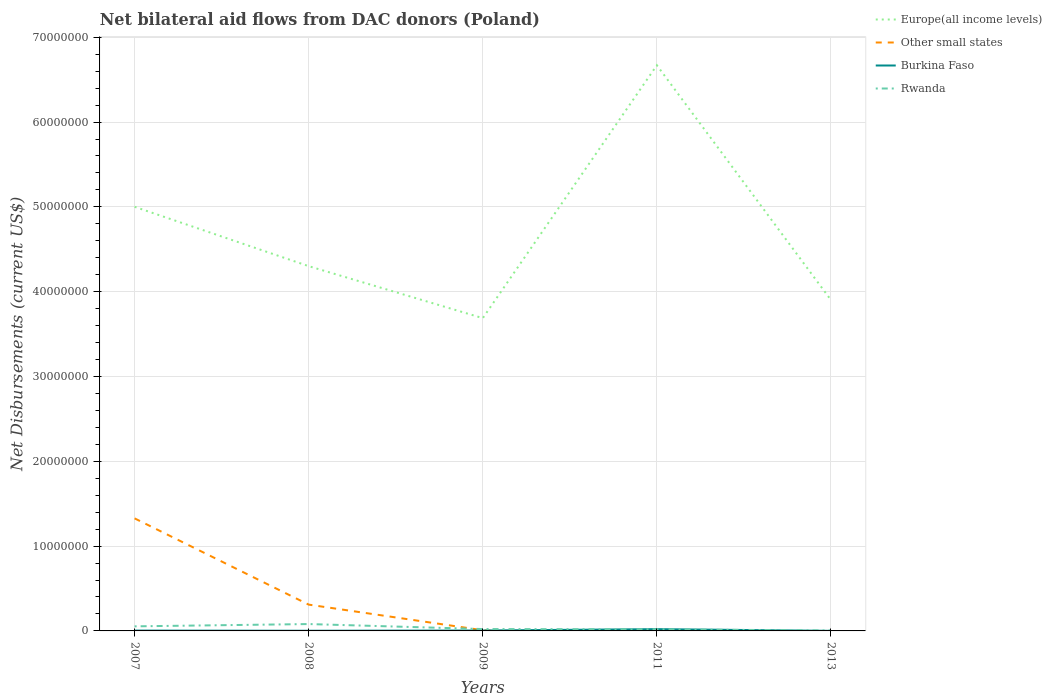Is the number of lines equal to the number of legend labels?
Offer a very short reply. No. What is the total net bilateral aid flows in Europe(all income levels) in the graph?
Give a very brief answer. 6.13e+06. What is the difference between the highest and the second highest net bilateral aid flows in Europe(all income levels)?
Your answer should be very brief. 2.98e+07. What is the difference between the highest and the lowest net bilateral aid flows in Burkina Faso?
Make the answer very short. 1. Is the net bilateral aid flows in Rwanda strictly greater than the net bilateral aid flows in Other small states over the years?
Your response must be concise. No. How many years are there in the graph?
Give a very brief answer. 5. What is the difference between two consecutive major ticks on the Y-axis?
Your answer should be very brief. 1.00e+07. How are the legend labels stacked?
Ensure brevity in your answer.  Vertical. What is the title of the graph?
Your response must be concise. Net bilateral aid flows from DAC donors (Poland). What is the label or title of the X-axis?
Give a very brief answer. Years. What is the label or title of the Y-axis?
Offer a very short reply. Net Disbursements (current US$). What is the Net Disbursements (current US$) in Europe(all income levels) in 2007?
Give a very brief answer. 5.00e+07. What is the Net Disbursements (current US$) of Other small states in 2007?
Your response must be concise. 1.33e+07. What is the Net Disbursements (current US$) of Burkina Faso in 2007?
Your answer should be very brief. 4.00e+04. What is the Net Disbursements (current US$) of Rwanda in 2007?
Ensure brevity in your answer.  5.40e+05. What is the Net Disbursements (current US$) of Europe(all income levels) in 2008?
Your answer should be very brief. 4.30e+07. What is the Net Disbursements (current US$) of Other small states in 2008?
Your response must be concise. 3.10e+06. What is the Net Disbursements (current US$) in Rwanda in 2008?
Provide a succinct answer. 8.10e+05. What is the Net Disbursements (current US$) in Europe(all income levels) in 2009?
Provide a succinct answer. 3.69e+07. What is the Net Disbursements (current US$) in Other small states in 2009?
Your answer should be very brief. 8.00e+04. What is the Net Disbursements (current US$) of Rwanda in 2009?
Provide a succinct answer. 2.20e+05. What is the Net Disbursements (current US$) in Europe(all income levels) in 2011?
Keep it short and to the point. 6.67e+07. What is the Net Disbursements (current US$) of Other small states in 2011?
Make the answer very short. 0. What is the Net Disbursements (current US$) in Europe(all income levels) in 2013?
Make the answer very short. 3.90e+07. Across all years, what is the maximum Net Disbursements (current US$) of Europe(all income levels)?
Give a very brief answer. 6.67e+07. Across all years, what is the maximum Net Disbursements (current US$) of Other small states?
Give a very brief answer. 1.33e+07. Across all years, what is the maximum Net Disbursements (current US$) in Burkina Faso?
Ensure brevity in your answer.  2.10e+05. Across all years, what is the maximum Net Disbursements (current US$) in Rwanda?
Make the answer very short. 8.10e+05. Across all years, what is the minimum Net Disbursements (current US$) in Europe(all income levels)?
Provide a short and direct response. 3.69e+07. What is the total Net Disbursements (current US$) of Europe(all income levels) in the graph?
Offer a very short reply. 2.36e+08. What is the total Net Disbursements (current US$) in Other small states in the graph?
Make the answer very short. 1.64e+07. What is the total Net Disbursements (current US$) of Rwanda in the graph?
Provide a succinct answer. 1.81e+06. What is the difference between the Net Disbursements (current US$) in Other small states in 2007 and that in 2008?
Provide a succinct answer. 1.02e+07. What is the difference between the Net Disbursements (current US$) in Europe(all income levels) in 2007 and that in 2009?
Your answer should be very brief. 1.31e+07. What is the difference between the Net Disbursements (current US$) of Other small states in 2007 and that in 2009?
Provide a short and direct response. 1.32e+07. What is the difference between the Net Disbursements (current US$) in Burkina Faso in 2007 and that in 2009?
Ensure brevity in your answer.  -10000. What is the difference between the Net Disbursements (current US$) in Rwanda in 2007 and that in 2009?
Your answer should be compact. 3.20e+05. What is the difference between the Net Disbursements (current US$) in Europe(all income levels) in 2007 and that in 2011?
Provide a succinct answer. -1.67e+07. What is the difference between the Net Disbursements (current US$) of Rwanda in 2007 and that in 2011?
Ensure brevity in your answer.  3.50e+05. What is the difference between the Net Disbursements (current US$) of Europe(all income levels) in 2007 and that in 2013?
Keep it short and to the point. 1.10e+07. What is the difference between the Net Disbursements (current US$) of Europe(all income levels) in 2008 and that in 2009?
Offer a terse response. 6.13e+06. What is the difference between the Net Disbursements (current US$) of Other small states in 2008 and that in 2009?
Ensure brevity in your answer.  3.02e+06. What is the difference between the Net Disbursements (current US$) in Rwanda in 2008 and that in 2009?
Give a very brief answer. 5.90e+05. What is the difference between the Net Disbursements (current US$) of Europe(all income levels) in 2008 and that in 2011?
Provide a short and direct response. -2.37e+07. What is the difference between the Net Disbursements (current US$) of Rwanda in 2008 and that in 2011?
Your answer should be compact. 6.20e+05. What is the difference between the Net Disbursements (current US$) of Europe(all income levels) in 2008 and that in 2013?
Your response must be concise. 3.99e+06. What is the difference between the Net Disbursements (current US$) of Burkina Faso in 2008 and that in 2013?
Ensure brevity in your answer.  10000. What is the difference between the Net Disbursements (current US$) in Rwanda in 2008 and that in 2013?
Ensure brevity in your answer.  7.60e+05. What is the difference between the Net Disbursements (current US$) of Europe(all income levels) in 2009 and that in 2011?
Offer a terse response. -2.98e+07. What is the difference between the Net Disbursements (current US$) in Rwanda in 2009 and that in 2011?
Provide a succinct answer. 3.00e+04. What is the difference between the Net Disbursements (current US$) in Europe(all income levels) in 2009 and that in 2013?
Give a very brief answer. -2.14e+06. What is the difference between the Net Disbursements (current US$) of Burkina Faso in 2009 and that in 2013?
Offer a terse response. 4.00e+04. What is the difference between the Net Disbursements (current US$) in Europe(all income levels) in 2011 and that in 2013?
Your answer should be very brief. 2.77e+07. What is the difference between the Net Disbursements (current US$) in Rwanda in 2011 and that in 2013?
Ensure brevity in your answer.  1.40e+05. What is the difference between the Net Disbursements (current US$) in Europe(all income levels) in 2007 and the Net Disbursements (current US$) in Other small states in 2008?
Your response must be concise. 4.69e+07. What is the difference between the Net Disbursements (current US$) of Europe(all income levels) in 2007 and the Net Disbursements (current US$) of Burkina Faso in 2008?
Your answer should be very brief. 5.00e+07. What is the difference between the Net Disbursements (current US$) of Europe(all income levels) in 2007 and the Net Disbursements (current US$) of Rwanda in 2008?
Your answer should be very brief. 4.92e+07. What is the difference between the Net Disbursements (current US$) of Other small states in 2007 and the Net Disbursements (current US$) of Burkina Faso in 2008?
Offer a terse response. 1.32e+07. What is the difference between the Net Disbursements (current US$) in Other small states in 2007 and the Net Disbursements (current US$) in Rwanda in 2008?
Your answer should be very brief. 1.25e+07. What is the difference between the Net Disbursements (current US$) in Burkina Faso in 2007 and the Net Disbursements (current US$) in Rwanda in 2008?
Your answer should be very brief. -7.70e+05. What is the difference between the Net Disbursements (current US$) of Europe(all income levels) in 2007 and the Net Disbursements (current US$) of Other small states in 2009?
Offer a terse response. 4.99e+07. What is the difference between the Net Disbursements (current US$) in Europe(all income levels) in 2007 and the Net Disbursements (current US$) in Burkina Faso in 2009?
Ensure brevity in your answer.  5.00e+07. What is the difference between the Net Disbursements (current US$) of Europe(all income levels) in 2007 and the Net Disbursements (current US$) of Rwanda in 2009?
Give a very brief answer. 4.98e+07. What is the difference between the Net Disbursements (current US$) of Other small states in 2007 and the Net Disbursements (current US$) of Burkina Faso in 2009?
Ensure brevity in your answer.  1.32e+07. What is the difference between the Net Disbursements (current US$) of Other small states in 2007 and the Net Disbursements (current US$) of Rwanda in 2009?
Your response must be concise. 1.30e+07. What is the difference between the Net Disbursements (current US$) of Burkina Faso in 2007 and the Net Disbursements (current US$) of Rwanda in 2009?
Keep it short and to the point. -1.80e+05. What is the difference between the Net Disbursements (current US$) of Europe(all income levels) in 2007 and the Net Disbursements (current US$) of Burkina Faso in 2011?
Offer a very short reply. 4.98e+07. What is the difference between the Net Disbursements (current US$) of Europe(all income levels) in 2007 and the Net Disbursements (current US$) of Rwanda in 2011?
Your answer should be very brief. 4.98e+07. What is the difference between the Net Disbursements (current US$) in Other small states in 2007 and the Net Disbursements (current US$) in Burkina Faso in 2011?
Provide a short and direct response. 1.31e+07. What is the difference between the Net Disbursements (current US$) in Other small states in 2007 and the Net Disbursements (current US$) in Rwanda in 2011?
Offer a terse response. 1.31e+07. What is the difference between the Net Disbursements (current US$) in Europe(all income levels) in 2007 and the Net Disbursements (current US$) in Rwanda in 2013?
Provide a succinct answer. 5.00e+07. What is the difference between the Net Disbursements (current US$) in Other small states in 2007 and the Net Disbursements (current US$) in Burkina Faso in 2013?
Give a very brief answer. 1.33e+07. What is the difference between the Net Disbursements (current US$) in Other small states in 2007 and the Net Disbursements (current US$) in Rwanda in 2013?
Make the answer very short. 1.32e+07. What is the difference between the Net Disbursements (current US$) in Europe(all income levels) in 2008 and the Net Disbursements (current US$) in Other small states in 2009?
Your answer should be very brief. 4.29e+07. What is the difference between the Net Disbursements (current US$) in Europe(all income levels) in 2008 and the Net Disbursements (current US$) in Burkina Faso in 2009?
Provide a succinct answer. 4.30e+07. What is the difference between the Net Disbursements (current US$) in Europe(all income levels) in 2008 and the Net Disbursements (current US$) in Rwanda in 2009?
Make the answer very short. 4.28e+07. What is the difference between the Net Disbursements (current US$) of Other small states in 2008 and the Net Disbursements (current US$) of Burkina Faso in 2009?
Provide a short and direct response. 3.05e+06. What is the difference between the Net Disbursements (current US$) of Other small states in 2008 and the Net Disbursements (current US$) of Rwanda in 2009?
Offer a terse response. 2.88e+06. What is the difference between the Net Disbursements (current US$) of Europe(all income levels) in 2008 and the Net Disbursements (current US$) of Burkina Faso in 2011?
Give a very brief answer. 4.28e+07. What is the difference between the Net Disbursements (current US$) of Europe(all income levels) in 2008 and the Net Disbursements (current US$) of Rwanda in 2011?
Offer a terse response. 4.28e+07. What is the difference between the Net Disbursements (current US$) in Other small states in 2008 and the Net Disbursements (current US$) in Burkina Faso in 2011?
Give a very brief answer. 2.89e+06. What is the difference between the Net Disbursements (current US$) of Other small states in 2008 and the Net Disbursements (current US$) of Rwanda in 2011?
Make the answer very short. 2.91e+06. What is the difference between the Net Disbursements (current US$) of Europe(all income levels) in 2008 and the Net Disbursements (current US$) of Burkina Faso in 2013?
Make the answer very short. 4.30e+07. What is the difference between the Net Disbursements (current US$) in Europe(all income levels) in 2008 and the Net Disbursements (current US$) in Rwanda in 2013?
Provide a short and direct response. 4.30e+07. What is the difference between the Net Disbursements (current US$) in Other small states in 2008 and the Net Disbursements (current US$) in Burkina Faso in 2013?
Offer a terse response. 3.09e+06. What is the difference between the Net Disbursements (current US$) in Other small states in 2008 and the Net Disbursements (current US$) in Rwanda in 2013?
Your answer should be compact. 3.05e+06. What is the difference between the Net Disbursements (current US$) in Europe(all income levels) in 2009 and the Net Disbursements (current US$) in Burkina Faso in 2011?
Offer a very short reply. 3.67e+07. What is the difference between the Net Disbursements (current US$) of Europe(all income levels) in 2009 and the Net Disbursements (current US$) of Rwanda in 2011?
Make the answer very short. 3.67e+07. What is the difference between the Net Disbursements (current US$) of Other small states in 2009 and the Net Disbursements (current US$) of Rwanda in 2011?
Keep it short and to the point. -1.10e+05. What is the difference between the Net Disbursements (current US$) of Europe(all income levels) in 2009 and the Net Disbursements (current US$) of Burkina Faso in 2013?
Your answer should be very brief. 3.69e+07. What is the difference between the Net Disbursements (current US$) of Europe(all income levels) in 2009 and the Net Disbursements (current US$) of Rwanda in 2013?
Your answer should be compact. 3.68e+07. What is the difference between the Net Disbursements (current US$) of Other small states in 2009 and the Net Disbursements (current US$) of Burkina Faso in 2013?
Your answer should be compact. 7.00e+04. What is the difference between the Net Disbursements (current US$) of Europe(all income levels) in 2011 and the Net Disbursements (current US$) of Burkina Faso in 2013?
Keep it short and to the point. 6.67e+07. What is the difference between the Net Disbursements (current US$) of Europe(all income levels) in 2011 and the Net Disbursements (current US$) of Rwanda in 2013?
Your response must be concise. 6.66e+07. What is the average Net Disbursements (current US$) in Europe(all income levels) per year?
Ensure brevity in your answer.  4.71e+07. What is the average Net Disbursements (current US$) of Other small states per year?
Offer a terse response. 3.29e+06. What is the average Net Disbursements (current US$) of Burkina Faso per year?
Your answer should be compact. 6.60e+04. What is the average Net Disbursements (current US$) in Rwanda per year?
Offer a terse response. 3.62e+05. In the year 2007, what is the difference between the Net Disbursements (current US$) in Europe(all income levels) and Net Disbursements (current US$) in Other small states?
Give a very brief answer. 3.67e+07. In the year 2007, what is the difference between the Net Disbursements (current US$) in Europe(all income levels) and Net Disbursements (current US$) in Burkina Faso?
Your response must be concise. 5.00e+07. In the year 2007, what is the difference between the Net Disbursements (current US$) in Europe(all income levels) and Net Disbursements (current US$) in Rwanda?
Offer a very short reply. 4.95e+07. In the year 2007, what is the difference between the Net Disbursements (current US$) of Other small states and Net Disbursements (current US$) of Burkina Faso?
Offer a very short reply. 1.32e+07. In the year 2007, what is the difference between the Net Disbursements (current US$) in Other small states and Net Disbursements (current US$) in Rwanda?
Your answer should be compact. 1.27e+07. In the year 2007, what is the difference between the Net Disbursements (current US$) in Burkina Faso and Net Disbursements (current US$) in Rwanda?
Your answer should be very brief. -5.00e+05. In the year 2008, what is the difference between the Net Disbursements (current US$) of Europe(all income levels) and Net Disbursements (current US$) of Other small states?
Your response must be concise. 3.99e+07. In the year 2008, what is the difference between the Net Disbursements (current US$) of Europe(all income levels) and Net Disbursements (current US$) of Burkina Faso?
Your response must be concise. 4.30e+07. In the year 2008, what is the difference between the Net Disbursements (current US$) of Europe(all income levels) and Net Disbursements (current US$) of Rwanda?
Offer a terse response. 4.22e+07. In the year 2008, what is the difference between the Net Disbursements (current US$) of Other small states and Net Disbursements (current US$) of Burkina Faso?
Provide a succinct answer. 3.08e+06. In the year 2008, what is the difference between the Net Disbursements (current US$) of Other small states and Net Disbursements (current US$) of Rwanda?
Offer a very short reply. 2.29e+06. In the year 2008, what is the difference between the Net Disbursements (current US$) in Burkina Faso and Net Disbursements (current US$) in Rwanda?
Provide a short and direct response. -7.90e+05. In the year 2009, what is the difference between the Net Disbursements (current US$) in Europe(all income levels) and Net Disbursements (current US$) in Other small states?
Provide a short and direct response. 3.68e+07. In the year 2009, what is the difference between the Net Disbursements (current US$) in Europe(all income levels) and Net Disbursements (current US$) in Burkina Faso?
Your answer should be very brief. 3.68e+07. In the year 2009, what is the difference between the Net Disbursements (current US$) in Europe(all income levels) and Net Disbursements (current US$) in Rwanda?
Provide a succinct answer. 3.67e+07. In the year 2009, what is the difference between the Net Disbursements (current US$) of Other small states and Net Disbursements (current US$) of Burkina Faso?
Give a very brief answer. 3.00e+04. In the year 2009, what is the difference between the Net Disbursements (current US$) of Other small states and Net Disbursements (current US$) of Rwanda?
Your answer should be very brief. -1.40e+05. In the year 2009, what is the difference between the Net Disbursements (current US$) of Burkina Faso and Net Disbursements (current US$) of Rwanda?
Ensure brevity in your answer.  -1.70e+05. In the year 2011, what is the difference between the Net Disbursements (current US$) of Europe(all income levels) and Net Disbursements (current US$) of Burkina Faso?
Your answer should be compact. 6.65e+07. In the year 2011, what is the difference between the Net Disbursements (current US$) in Europe(all income levels) and Net Disbursements (current US$) in Rwanda?
Your response must be concise. 6.65e+07. In the year 2013, what is the difference between the Net Disbursements (current US$) of Europe(all income levels) and Net Disbursements (current US$) of Burkina Faso?
Give a very brief answer. 3.90e+07. In the year 2013, what is the difference between the Net Disbursements (current US$) of Europe(all income levels) and Net Disbursements (current US$) of Rwanda?
Your answer should be very brief. 3.90e+07. In the year 2013, what is the difference between the Net Disbursements (current US$) in Burkina Faso and Net Disbursements (current US$) in Rwanda?
Make the answer very short. -4.00e+04. What is the ratio of the Net Disbursements (current US$) in Europe(all income levels) in 2007 to that in 2008?
Offer a very short reply. 1.16. What is the ratio of the Net Disbursements (current US$) of Other small states in 2007 to that in 2008?
Your answer should be compact. 4.28. What is the ratio of the Net Disbursements (current US$) in Burkina Faso in 2007 to that in 2008?
Keep it short and to the point. 2. What is the ratio of the Net Disbursements (current US$) in Rwanda in 2007 to that in 2008?
Provide a short and direct response. 0.67. What is the ratio of the Net Disbursements (current US$) in Europe(all income levels) in 2007 to that in 2009?
Keep it short and to the point. 1.36. What is the ratio of the Net Disbursements (current US$) in Other small states in 2007 to that in 2009?
Your answer should be very brief. 165.88. What is the ratio of the Net Disbursements (current US$) of Burkina Faso in 2007 to that in 2009?
Your answer should be compact. 0.8. What is the ratio of the Net Disbursements (current US$) in Rwanda in 2007 to that in 2009?
Give a very brief answer. 2.45. What is the ratio of the Net Disbursements (current US$) of Europe(all income levels) in 2007 to that in 2011?
Ensure brevity in your answer.  0.75. What is the ratio of the Net Disbursements (current US$) of Burkina Faso in 2007 to that in 2011?
Keep it short and to the point. 0.19. What is the ratio of the Net Disbursements (current US$) of Rwanda in 2007 to that in 2011?
Make the answer very short. 2.84. What is the ratio of the Net Disbursements (current US$) in Europe(all income levels) in 2007 to that in 2013?
Offer a terse response. 1.28. What is the ratio of the Net Disbursements (current US$) in Burkina Faso in 2007 to that in 2013?
Your answer should be very brief. 4. What is the ratio of the Net Disbursements (current US$) of Rwanda in 2007 to that in 2013?
Your answer should be compact. 10.8. What is the ratio of the Net Disbursements (current US$) in Europe(all income levels) in 2008 to that in 2009?
Your answer should be very brief. 1.17. What is the ratio of the Net Disbursements (current US$) in Other small states in 2008 to that in 2009?
Offer a terse response. 38.75. What is the ratio of the Net Disbursements (current US$) of Burkina Faso in 2008 to that in 2009?
Provide a short and direct response. 0.4. What is the ratio of the Net Disbursements (current US$) in Rwanda in 2008 to that in 2009?
Your response must be concise. 3.68. What is the ratio of the Net Disbursements (current US$) in Europe(all income levels) in 2008 to that in 2011?
Provide a succinct answer. 0.64. What is the ratio of the Net Disbursements (current US$) of Burkina Faso in 2008 to that in 2011?
Provide a short and direct response. 0.1. What is the ratio of the Net Disbursements (current US$) in Rwanda in 2008 to that in 2011?
Keep it short and to the point. 4.26. What is the ratio of the Net Disbursements (current US$) of Europe(all income levels) in 2008 to that in 2013?
Your answer should be very brief. 1.1. What is the ratio of the Net Disbursements (current US$) in Burkina Faso in 2008 to that in 2013?
Make the answer very short. 2. What is the ratio of the Net Disbursements (current US$) in Rwanda in 2008 to that in 2013?
Your answer should be compact. 16.2. What is the ratio of the Net Disbursements (current US$) of Europe(all income levels) in 2009 to that in 2011?
Ensure brevity in your answer.  0.55. What is the ratio of the Net Disbursements (current US$) of Burkina Faso in 2009 to that in 2011?
Your answer should be very brief. 0.24. What is the ratio of the Net Disbursements (current US$) of Rwanda in 2009 to that in 2011?
Your answer should be very brief. 1.16. What is the ratio of the Net Disbursements (current US$) in Europe(all income levels) in 2009 to that in 2013?
Offer a very short reply. 0.95. What is the ratio of the Net Disbursements (current US$) in Burkina Faso in 2009 to that in 2013?
Provide a succinct answer. 5. What is the ratio of the Net Disbursements (current US$) in Rwanda in 2009 to that in 2013?
Give a very brief answer. 4.4. What is the ratio of the Net Disbursements (current US$) in Europe(all income levels) in 2011 to that in 2013?
Make the answer very short. 1.71. What is the difference between the highest and the second highest Net Disbursements (current US$) in Europe(all income levels)?
Offer a very short reply. 1.67e+07. What is the difference between the highest and the second highest Net Disbursements (current US$) in Other small states?
Provide a succinct answer. 1.02e+07. What is the difference between the highest and the lowest Net Disbursements (current US$) in Europe(all income levels)?
Offer a terse response. 2.98e+07. What is the difference between the highest and the lowest Net Disbursements (current US$) in Other small states?
Ensure brevity in your answer.  1.33e+07. What is the difference between the highest and the lowest Net Disbursements (current US$) of Burkina Faso?
Give a very brief answer. 2.00e+05. What is the difference between the highest and the lowest Net Disbursements (current US$) of Rwanda?
Offer a very short reply. 7.60e+05. 